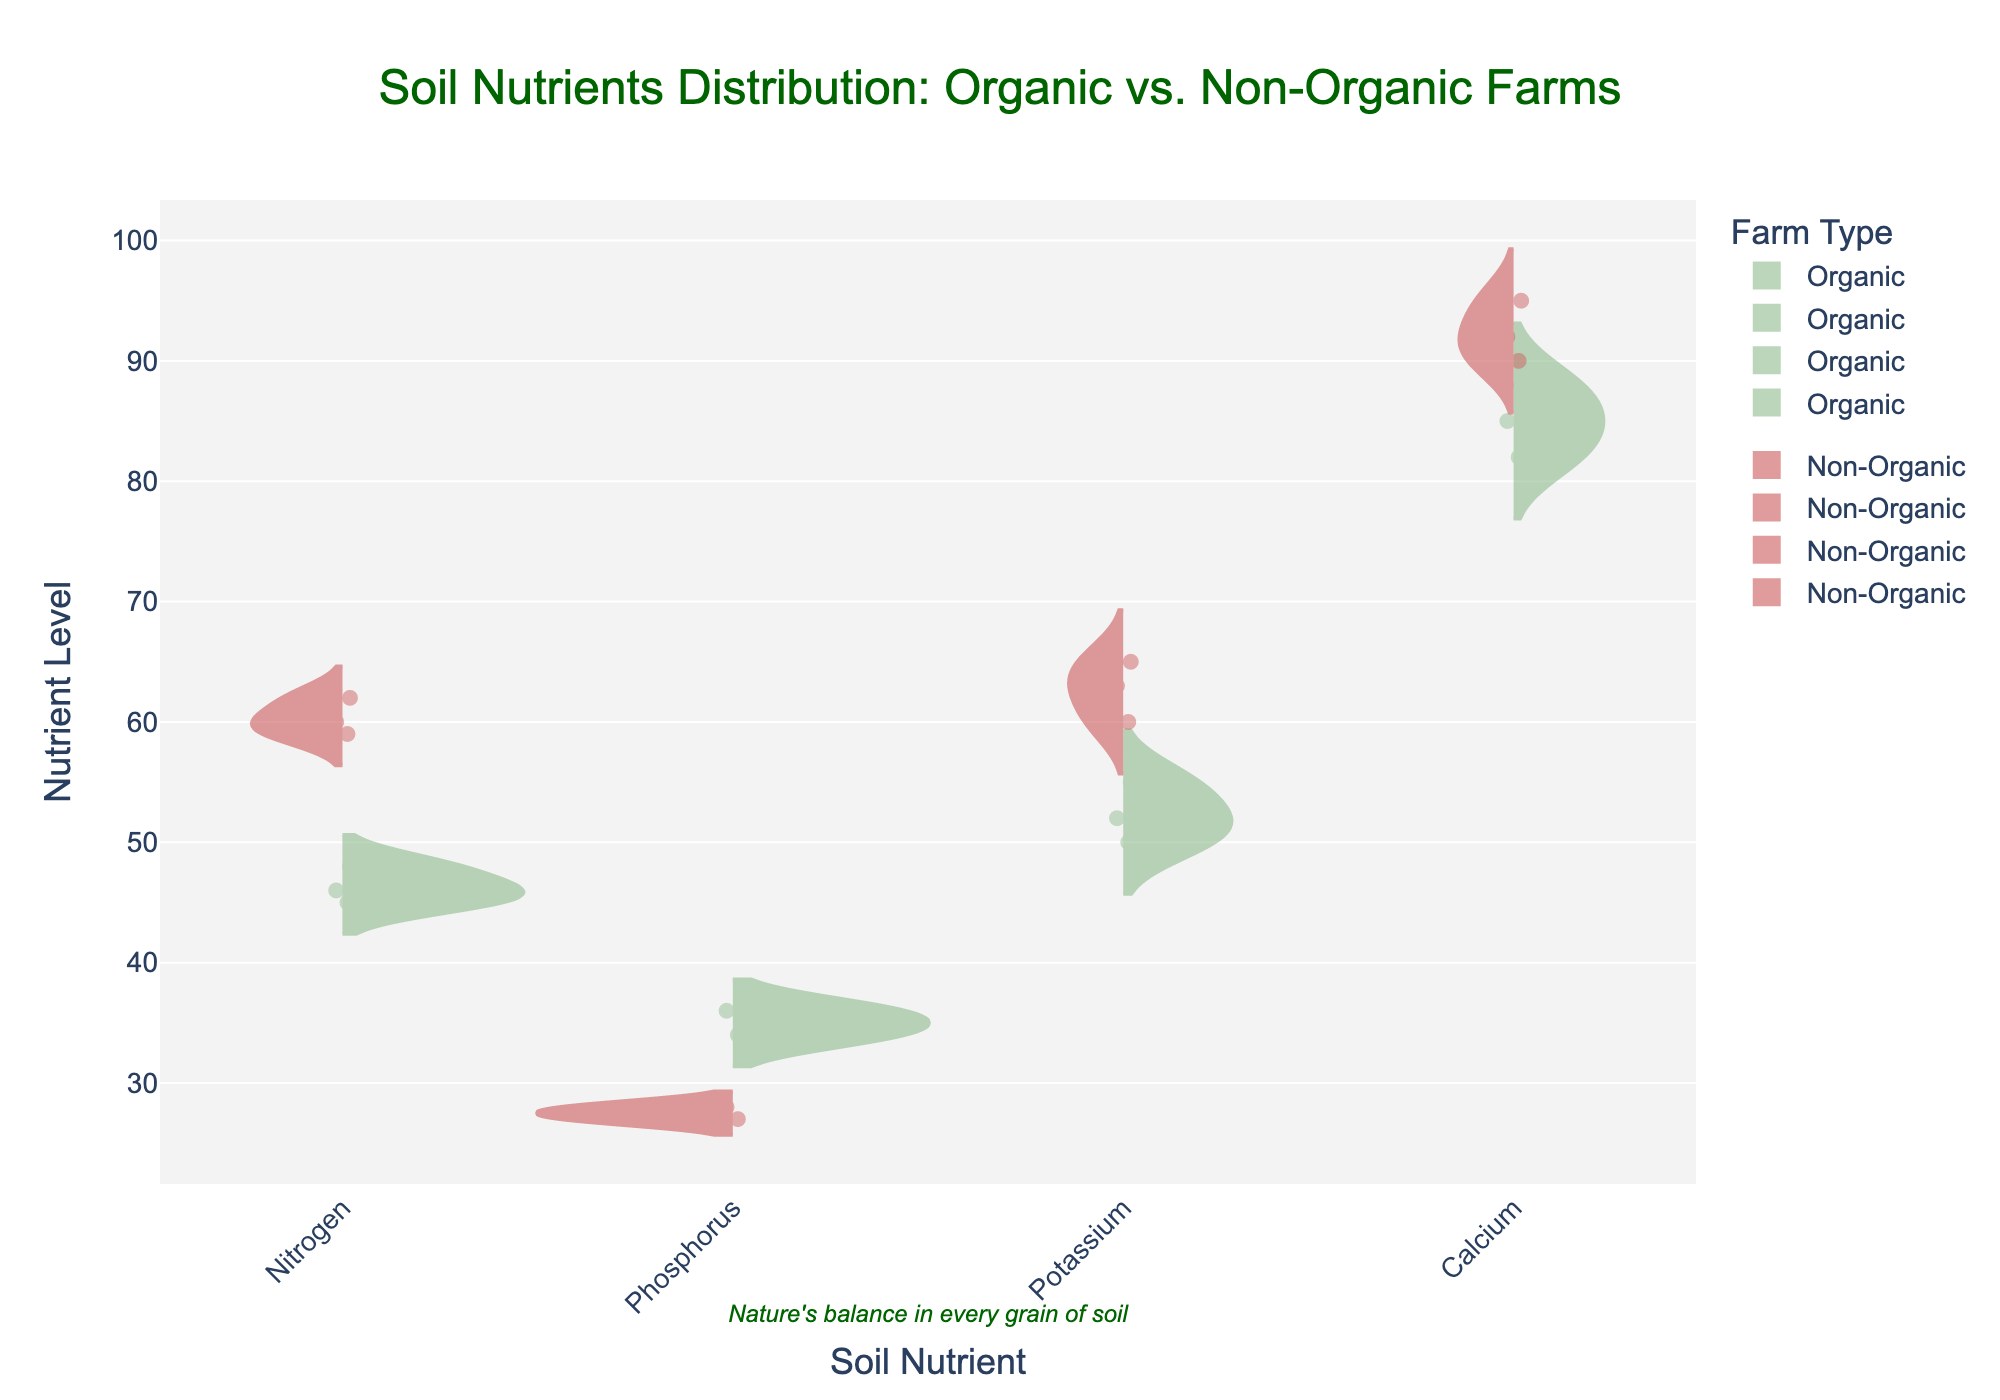What is the title of the figure? The title is often placed at the top of the chart. Here, it indicates what the chart is about.
Answer: Soil Nutrients Distribution: Organic vs. Non-Organic Farms How many soil nutrients are compared in the figure? The x-axis shows the categories of nutrients being compared. Count the distinct labels.
Answer: Four Which farm type has a higher median nitrogen level? The violin plot includes a median line. Compare the median lines for Organic and Non-Organic farms for nitrogen.
Answer: Non-Organic What is the average potassium level for Organic farms? Look at the data points distribution within the Organic section of the potassium violin plot. Calculate the average of [52, 55, 50]. (52 + 55 + 50)/3 = 52.33.
Answer: 52.33 Which nutrient has the highest overall variability in Organic farms? Variability can be inferred from the spread of the violin plot. Compare the spreads of the violins in each nutrient category for Organic farms.
Answer: Calcium Is there any nutrient where Organic farms have a higher median level than Non-Organic farms? Compare the median lines for each nutrient's violin plots between Organic and Non-Organic farms.
Answer: Phosphorus What is the range of calcium levels for Non-Organic farms? The range is calculated by subtracting the minimum value from the maximum value within the Non-Organic section of the calcium violin plot. Non-Organic Calcium levels are [90, 95, 92], so the range is 95 - 90 = 5.
Answer: 5 Which farm type shows a wider distribution for phosphorus levels? Distribution width is shown by how spread out the violin plot is. Compare the width of the phosphorus plots for Organic and Non-Organic farms.
Answer: Organic How many data points are plotted for Organic phosphorus levels? Examine the number of individual points within the Organic section for phosphorus.
Answer: Two In which soil nutrient do both farm types have the closest median levels? Compare the median lines for both Organic and Non-Organic farms across all nutrients and see which are closest.
Answer: Potassium 